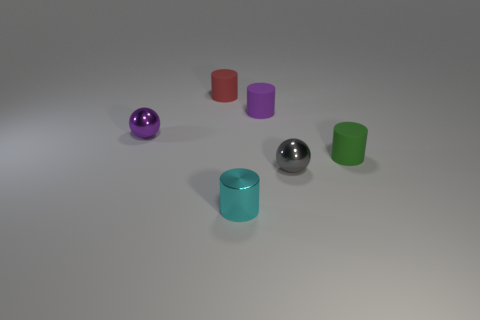What number of cyan matte things are the same size as the purple rubber cylinder?
Your answer should be very brief. 0. There is a sphere that is in front of the metallic sphere to the left of the gray metallic ball; what is it made of?
Your response must be concise. Metal. There is a small metallic object that is behind the matte cylinder that is to the right of the metallic ball that is on the right side of the tiny red thing; what is its shape?
Offer a terse response. Sphere. There is a small object on the left side of the tiny red object; is it the same shape as the tiny object in front of the gray sphere?
Offer a terse response. No. There is a small purple object that is made of the same material as the small cyan thing; what shape is it?
Provide a succinct answer. Sphere. Do the gray ball and the cyan metal cylinder have the same size?
Keep it short and to the point. Yes. What size is the purple object that is to the right of the shiny ball behind the small gray metallic sphere?
Offer a very short reply. Small. How many cubes are gray metal things or tiny objects?
Keep it short and to the point. 0. Are there more tiny cyan metallic objects that are to the right of the purple metal ball than small brown cubes?
Provide a succinct answer. Yes. What number of things are green cylinders or tiny cylinders that are to the left of the tiny gray shiny sphere?
Keep it short and to the point. 4. 